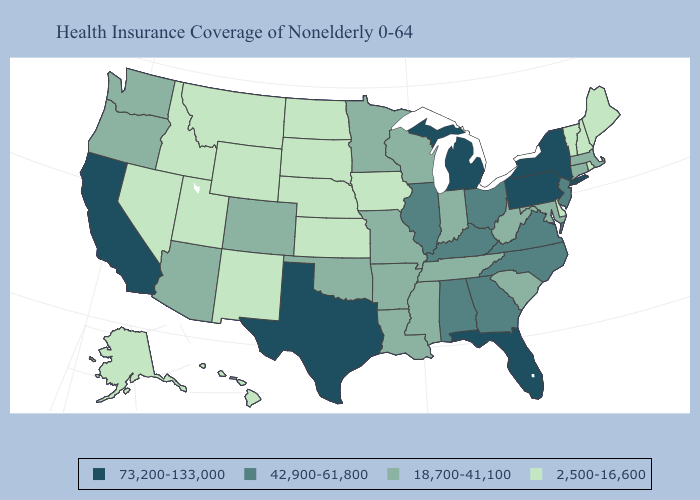Name the states that have a value in the range 18,700-41,100?
Write a very short answer. Arizona, Arkansas, Colorado, Connecticut, Indiana, Louisiana, Maryland, Massachusetts, Minnesota, Mississippi, Missouri, Oklahoma, Oregon, South Carolina, Tennessee, Washington, West Virginia, Wisconsin. Does Washington have the same value as South Dakota?
Keep it brief. No. Name the states that have a value in the range 73,200-133,000?
Answer briefly. California, Florida, Michigan, New York, Pennsylvania, Texas. What is the value of Pennsylvania?
Keep it brief. 73,200-133,000. Does the map have missing data?
Short answer required. No. Name the states that have a value in the range 73,200-133,000?
Short answer required. California, Florida, Michigan, New York, Pennsylvania, Texas. Name the states that have a value in the range 18,700-41,100?
Write a very short answer. Arizona, Arkansas, Colorado, Connecticut, Indiana, Louisiana, Maryland, Massachusetts, Minnesota, Mississippi, Missouri, Oklahoma, Oregon, South Carolina, Tennessee, Washington, West Virginia, Wisconsin. Does Texas have the highest value in the USA?
Give a very brief answer. Yes. What is the value of Indiana?
Keep it brief. 18,700-41,100. What is the highest value in states that border Texas?
Be succinct. 18,700-41,100. Which states hav the highest value in the South?
Be succinct. Florida, Texas. Does the first symbol in the legend represent the smallest category?
Concise answer only. No. Among the states that border Kansas , which have the highest value?
Write a very short answer. Colorado, Missouri, Oklahoma. Does Indiana have a higher value than South Carolina?
Give a very brief answer. No. 